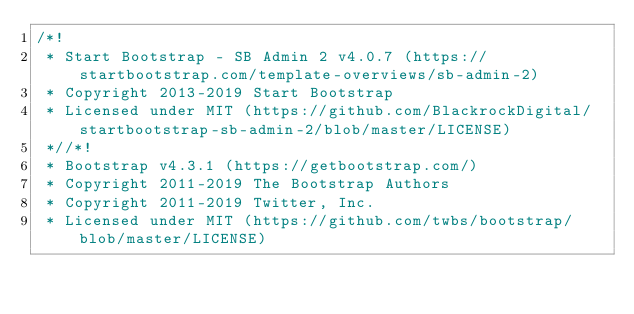Convert code to text. <code><loc_0><loc_0><loc_500><loc_500><_CSS_>/*!
 * Start Bootstrap - SB Admin 2 v4.0.7 (https://startbootstrap.com/template-overviews/sb-admin-2)
 * Copyright 2013-2019 Start Bootstrap
 * Licensed under MIT (https://github.com/BlackrockDigital/startbootstrap-sb-admin-2/blob/master/LICENSE)
 *//*!
 * Bootstrap v4.3.1 (https://getbootstrap.com/)
 * Copyright 2011-2019 The Bootstrap Authors
 * Copyright 2011-2019 Twitter, Inc.
 * Licensed under MIT (https://github.com/twbs/bootstrap/blob/master/LICENSE)</code> 